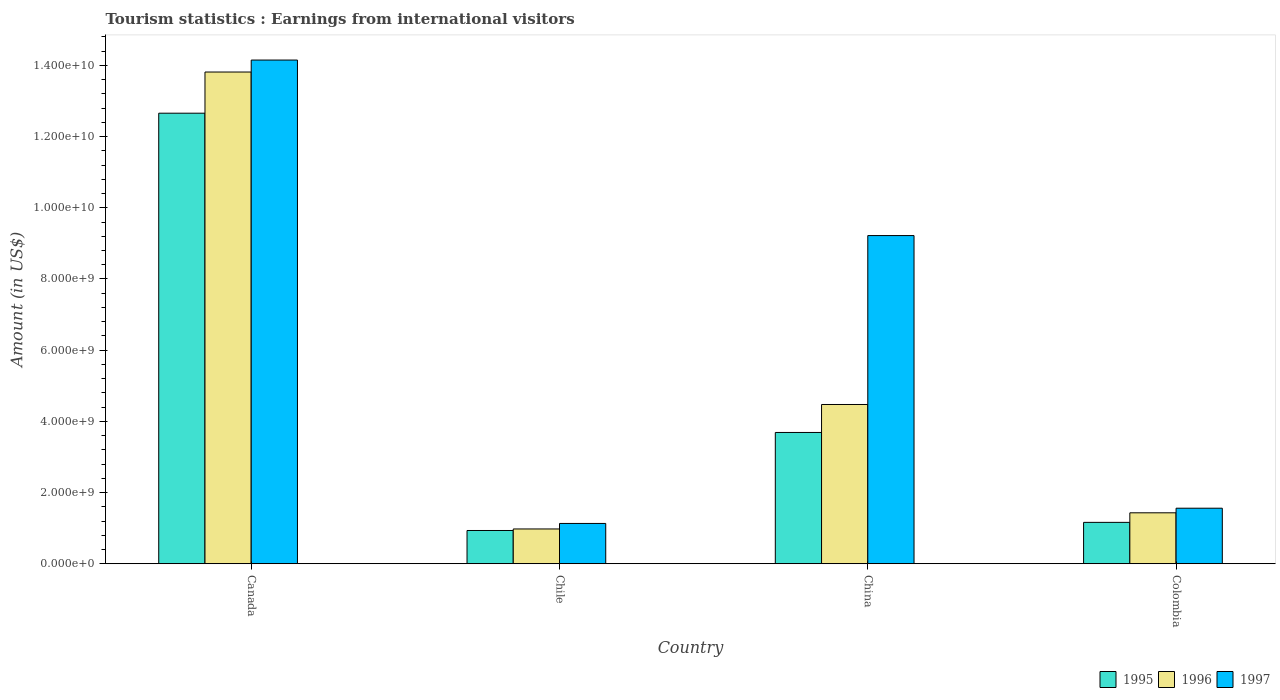How many groups of bars are there?
Your answer should be very brief. 4. Are the number of bars on each tick of the X-axis equal?
Make the answer very short. Yes. What is the label of the 3rd group of bars from the left?
Offer a terse response. China. What is the earnings from international visitors in 1996 in Canada?
Your response must be concise. 1.38e+1. Across all countries, what is the maximum earnings from international visitors in 1996?
Offer a terse response. 1.38e+1. Across all countries, what is the minimum earnings from international visitors in 1996?
Offer a terse response. 9.77e+08. In which country was the earnings from international visitors in 1996 minimum?
Give a very brief answer. Chile. What is the total earnings from international visitors in 1996 in the graph?
Provide a short and direct response. 2.07e+1. What is the difference between the earnings from international visitors in 1997 in Chile and that in Colombia?
Keep it short and to the point. -4.28e+08. What is the difference between the earnings from international visitors in 1997 in Canada and the earnings from international visitors in 1995 in China?
Offer a terse response. 1.05e+1. What is the average earnings from international visitors in 1996 per country?
Provide a short and direct response. 5.17e+09. What is the difference between the earnings from international visitors of/in 1997 and earnings from international visitors of/in 1996 in Chile?
Your response must be concise. 1.55e+08. In how many countries, is the earnings from international visitors in 1996 greater than 3200000000 US$?
Keep it short and to the point. 2. What is the ratio of the earnings from international visitors in 1996 in Canada to that in Chile?
Offer a terse response. 14.14. Is the difference between the earnings from international visitors in 1997 in China and Colombia greater than the difference between the earnings from international visitors in 1996 in China and Colombia?
Provide a short and direct response. Yes. What is the difference between the highest and the second highest earnings from international visitors in 1997?
Make the answer very short. 4.93e+09. What is the difference between the highest and the lowest earnings from international visitors in 1997?
Provide a succinct answer. 1.30e+1. In how many countries, is the earnings from international visitors in 1995 greater than the average earnings from international visitors in 1995 taken over all countries?
Your response must be concise. 1. What does the 1st bar from the left in Colombia represents?
Offer a very short reply. 1995. What does the 2nd bar from the right in Canada represents?
Make the answer very short. 1996. Is it the case that in every country, the sum of the earnings from international visitors in 1995 and earnings from international visitors in 1997 is greater than the earnings from international visitors in 1996?
Provide a short and direct response. Yes. How many bars are there?
Offer a very short reply. 12. How many countries are there in the graph?
Your response must be concise. 4. Are the values on the major ticks of Y-axis written in scientific E-notation?
Ensure brevity in your answer.  Yes. Does the graph contain any zero values?
Ensure brevity in your answer.  No. Where does the legend appear in the graph?
Offer a very short reply. Bottom right. How many legend labels are there?
Your response must be concise. 3. How are the legend labels stacked?
Your response must be concise. Horizontal. What is the title of the graph?
Provide a short and direct response. Tourism statistics : Earnings from international visitors. Does "1965" appear as one of the legend labels in the graph?
Give a very brief answer. No. What is the label or title of the Y-axis?
Provide a short and direct response. Amount (in US$). What is the Amount (in US$) of 1995 in Canada?
Ensure brevity in your answer.  1.27e+1. What is the Amount (in US$) in 1996 in Canada?
Offer a very short reply. 1.38e+1. What is the Amount (in US$) of 1997 in Canada?
Offer a very short reply. 1.42e+1. What is the Amount (in US$) of 1995 in Chile?
Offer a very short reply. 9.34e+08. What is the Amount (in US$) of 1996 in Chile?
Provide a short and direct response. 9.77e+08. What is the Amount (in US$) of 1997 in Chile?
Offer a terse response. 1.13e+09. What is the Amount (in US$) of 1995 in China?
Offer a terse response. 3.69e+09. What is the Amount (in US$) in 1996 in China?
Your answer should be very brief. 4.47e+09. What is the Amount (in US$) of 1997 in China?
Make the answer very short. 9.22e+09. What is the Amount (in US$) in 1995 in Colombia?
Your response must be concise. 1.16e+09. What is the Amount (in US$) in 1996 in Colombia?
Offer a very short reply. 1.43e+09. What is the Amount (in US$) of 1997 in Colombia?
Provide a succinct answer. 1.56e+09. Across all countries, what is the maximum Amount (in US$) in 1995?
Offer a terse response. 1.27e+1. Across all countries, what is the maximum Amount (in US$) in 1996?
Offer a very short reply. 1.38e+1. Across all countries, what is the maximum Amount (in US$) of 1997?
Keep it short and to the point. 1.42e+1. Across all countries, what is the minimum Amount (in US$) in 1995?
Give a very brief answer. 9.34e+08. Across all countries, what is the minimum Amount (in US$) in 1996?
Provide a succinct answer. 9.77e+08. Across all countries, what is the minimum Amount (in US$) of 1997?
Keep it short and to the point. 1.13e+09. What is the total Amount (in US$) of 1995 in the graph?
Make the answer very short. 1.84e+1. What is the total Amount (in US$) of 1996 in the graph?
Keep it short and to the point. 2.07e+1. What is the total Amount (in US$) of 1997 in the graph?
Make the answer very short. 2.61e+1. What is the difference between the Amount (in US$) in 1995 in Canada and that in Chile?
Offer a very short reply. 1.17e+1. What is the difference between the Amount (in US$) in 1996 in Canada and that in Chile?
Your response must be concise. 1.28e+1. What is the difference between the Amount (in US$) in 1997 in Canada and that in Chile?
Provide a short and direct response. 1.30e+1. What is the difference between the Amount (in US$) of 1995 in Canada and that in China?
Provide a succinct answer. 8.97e+09. What is the difference between the Amount (in US$) of 1996 in Canada and that in China?
Offer a terse response. 9.34e+09. What is the difference between the Amount (in US$) of 1997 in Canada and that in China?
Provide a short and direct response. 4.93e+09. What is the difference between the Amount (in US$) in 1995 in Canada and that in Colombia?
Your response must be concise. 1.15e+1. What is the difference between the Amount (in US$) in 1996 in Canada and that in Colombia?
Your answer should be very brief. 1.24e+1. What is the difference between the Amount (in US$) in 1997 in Canada and that in Colombia?
Make the answer very short. 1.26e+1. What is the difference between the Amount (in US$) of 1995 in Chile and that in China?
Keep it short and to the point. -2.75e+09. What is the difference between the Amount (in US$) in 1996 in Chile and that in China?
Provide a short and direct response. -3.50e+09. What is the difference between the Amount (in US$) in 1997 in Chile and that in China?
Your answer should be compact. -8.09e+09. What is the difference between the Amount (in US$) in 1995 in Chile and that in Colombia?
Your response must be concise. -2.28e+08. What is the difference between the Amount (in US$) in 1996 in Chile and that in Colombia?
Your answer should be compact. -4.54e+08. What is the difference between the Amount (in US$) in 1997 in Chile and that in Colombia?
Make the answer very short. -4.28e+08. What is the difference between the Amount (in US$) of 1995 in China and that in Colombia?
Offer a very short reply. 2.53e+09. What is the difference between the Amount (in US$) of 1996 in China and that in Colombia?
Offer a terse response. 3.04e+09. What is the difference between the Amount (in US$) in 1997 in China and that in Colombia?
Your answer should be compact. 7.66e+09. What is the difference between the Amount (in US$) of 1995 in Canada and the Amount (in US$) of 1996 in Chile?
Give a very brief answer. 1.17e+1. What is the difference between the Amount (in US$) of 1995 in Canada and the Amount (in US$) of 1997 in Chile?
Provide a short and direct response. 1.15e+1. What is the difference between the Amount (in US$) in 1996 in Canada and the Amount (in US$) in 1997 in Chile?
Ensure brevity in your answer.  1.27e+1. What is the difference between the Amount (in US$) in 1995 in Canada and the Amount (in US$) in 1996 in China?
Your answer should be very brief. 8.18e+09. What is the difference between the Amount (in US$) in 1995 in Canada and the Amount (in US$) in 1997 in China?
Provide a short and direct response. 3.44e+09. What is the difference between the Amount (in US$) in 1996 in Canada and the Amount (in US$) in 1997 in China?
Ensure brevity in your answer.  4.60e+09. What is the difference between the Amount (in US$) of 1995 in Canada and the Amount (in US$) of 1996 in Colombia?
Make the answer very short. 1.12e+1. What is the difference between the Amount (in US$) of 1995 in Canada and the Amount (in US$) of 1997 in Colombia?
Offer a very short reply. 1.11e+1. What is the difference between the Amount (in US$) of 1996 in Canada and the Amount (in US$) of 1997 in Colombia?
Offer a very short reply. 1.23e+1. What is the difference between the Amount (in US$) of 1995 in Chile and the Amount (in US$) of 1996 in China?
Make the answer very short. -3.54e+09. What is the difference between the Amount (in US$) of 1995 in Chile and the Amount (in US$) of 1997 in China?
Provide a short and direct response. -8.29e+09. What is the difference between the Amount (in US$) of 1996 in Chile and the Amount (in US$) of 1997 in China?
Your response must be concise. -8.24e+09. What is the difference between the Amount (in US$) of 1995 in Chile and the Amount (in US$) of 1996 in Colombia?
Ensure brevity in your answer.  -4.97e+08. What is the difference between the Amount (in US$) in 1995 in Chile and the Amount (in US$) in 1997 in Colombia?
Give a very brief answer. -6.26e+08. What is the difference between the Amount (in US$) in 1996 in Chile and the Amount (in US$) in 1997 in Colombia?
Your answer should be very brief. -5.83e+08. What is the difference between the Amount (in US$) in 1995 in China and the Amount (in US$) in 1996 in Colombia?
Your answer should be very brief. 2.26e+09. What is the difference between the Amount (in US$) in 1995 in China and the Amount (in US$) in 1997 in Colombia?
Provide a short and direct response. 2.13e+09. What is the difference between the Amount (in US$) of 1996 in China and the Amount (in US$) of 1997 in Colombia?
Keep it short and to the point. 2.91e+09. What is the average Amount (in US$) in 1995 per country?
Provide a succinct answer. 4.61e+09. What is the average Amount (in US$) in 1996 per country?
Your response must be concise. 5.17e+09. What is the average Amount (in US$) in 1997 per country?
Provide a succinct answer. 6.52e+09. What is the difference between the Amount (in US$) of 1995 and Amount (in US$) of 1996 in Canada?
Your answer should be compact. -1.16e+09. What is the difference between the Amount (in US$) of 1995 and Amount (in US$) of 1997 in Canada?
Make the answer very short. -1.49e+09. What is the difference between the Amount (in US$) in 1996 and Amount (in US$) in 1997 in Canada?
Make the answer very short. -3.36e+08. What is the difference between the Amount (in US$) in 1995 and Amount (in US$) in 1996 in Chile?
Provide a short and direct response. -4.30e+07. What is the difference between the Amount (in US$) in 1995 and Amount (in US$) in 1997 in Chile?
Provide a succinct answer. -1.98e+08. What is the difference between the Amount (in US$) in 1996 and Amount (in US$) in 1997 in Chile?
Your answer should be very brief. -1.55e+08. What is the difference between the Amount (in US$) in 1995 and Amount (in US$) in 1996 in China?
Offer a very short reply. -7.86e+08. What is the difference between the Amount (in US$) in 1995 and Amount (in US$) in 1997 in China?
Keep it short and to the point. -5.53e+09. What is the difference between the Amount (in US$) in 1996 and Amount (in US$) in 1997 in China?
Offer a very short reply. -4.75e+09. What is the difference between the Amount (in US$) of 1995 and Amount (in US$) of 1996 in Colombia?
Offer a terse response. -2.69e+08. What is the difference between the Amount (in US$) in 1995 and Amount (in US$) in 1997 in Colombia?
Give a very brief answer. -3.98e+08. What is the difference between the Amount (in US$) in 1996 and Amount (in US$) in 1997 in Colombia?
Provide a short and direct response. -1.29e+08. What is the ratio of the Amount (in US$) of 1995 in Canada to that in Chile?
Make the answer very short. 13.55. What is the ratio of the Amount (in US$) in 1996 in Canada to that in Chile?
Offer a terse response. 14.14. What is the ratio of the Amount (in US$) in 1997 in Canada to that in Chile?
Your answer should be compact. 12.5. What is the ratio of the Amount (in US$) of 1995 in Canada to that in China?
Give a very brief answer. 3.43. What is the ratio of the Amount (in US$) in 1996 in Canada to that in China?
Keep it short and to the point. 3.09. What is the ratio of the Amount (in US$) of 1997 in Canada to that in China?
Make the answer very short. 1.53. What is the ratio of the Amount (in US$) of 1995 in Canada to that in Colombia?
Offer a terse response. 10.89. What is the ratio of the Amount (in US$) of 1996 in Canada to that in Colombia?
Ensure brevity in your answer.  9.65. What is the ratio of the Amount (in US$) in 1997 in Canada to that in Colombia?
Provide a succinct answer. 9.07. What is the ratio of the Amount (in US$) in 1995 in Chile to that in China?
Keep it short and to the point. 0.25. What is the ratio of the Amount (in US$) of 1996 in Chile to that in China?
Offer a very short reply. 0.22. What is the ratio of the Amount (in US$) in 1997 in Chile to that in China?
Your answer should be compact. 0.12. What is the ratio of the Amount (in US$) of 1995 in Chile to that in Colombia?
Offer a terse response. 0.8. What is the ratio of the Amount (in US$) in 1996 in Chile to that in Colombia?
Provide a succinct answer. 0.68. What is the ratio of the Amount (in US$) of 1997 in Chile to that in Colombia?
Your answer should be compact. 0.73. What is the ratio of the Amount (in US$) of 1995 in China to that in Colombia?
Give a very brief answer. 3.17. What is the ratio of the Amount (in US$) of 1996 in China to that in Colombia?
Keep it short and to the point. 3.13. What is the ratio of the Amount (in US$) in 1997 in China to that in Colombia?
Your answer should be very brief. 5.91. What is the difference between the highest and the second highest Amount (in US$) in 1995?
Give a very brief answer. 8.97e+09. What is the difference between the highest and the second highest Amount (in US$) of 1996?
Provide a succinct answer. 9.34e+09. What is the difference between the highest and the second highest Amount (in US$) of 1997?
Make the answer very short. 4.93e+09. What is the difference between the highest and the lowest Amount (in US$) of 1995?
Your answer should be compact. 1.17e+1. What is the difference between the highest and the lowest Amount (in US$) in 1996?
Provide a succinct answer. 1.28e+1. What is the difference between the highest and the lowest Amount (in US$) of 1997?
Provide a short and direct response. 1.30e+1. 